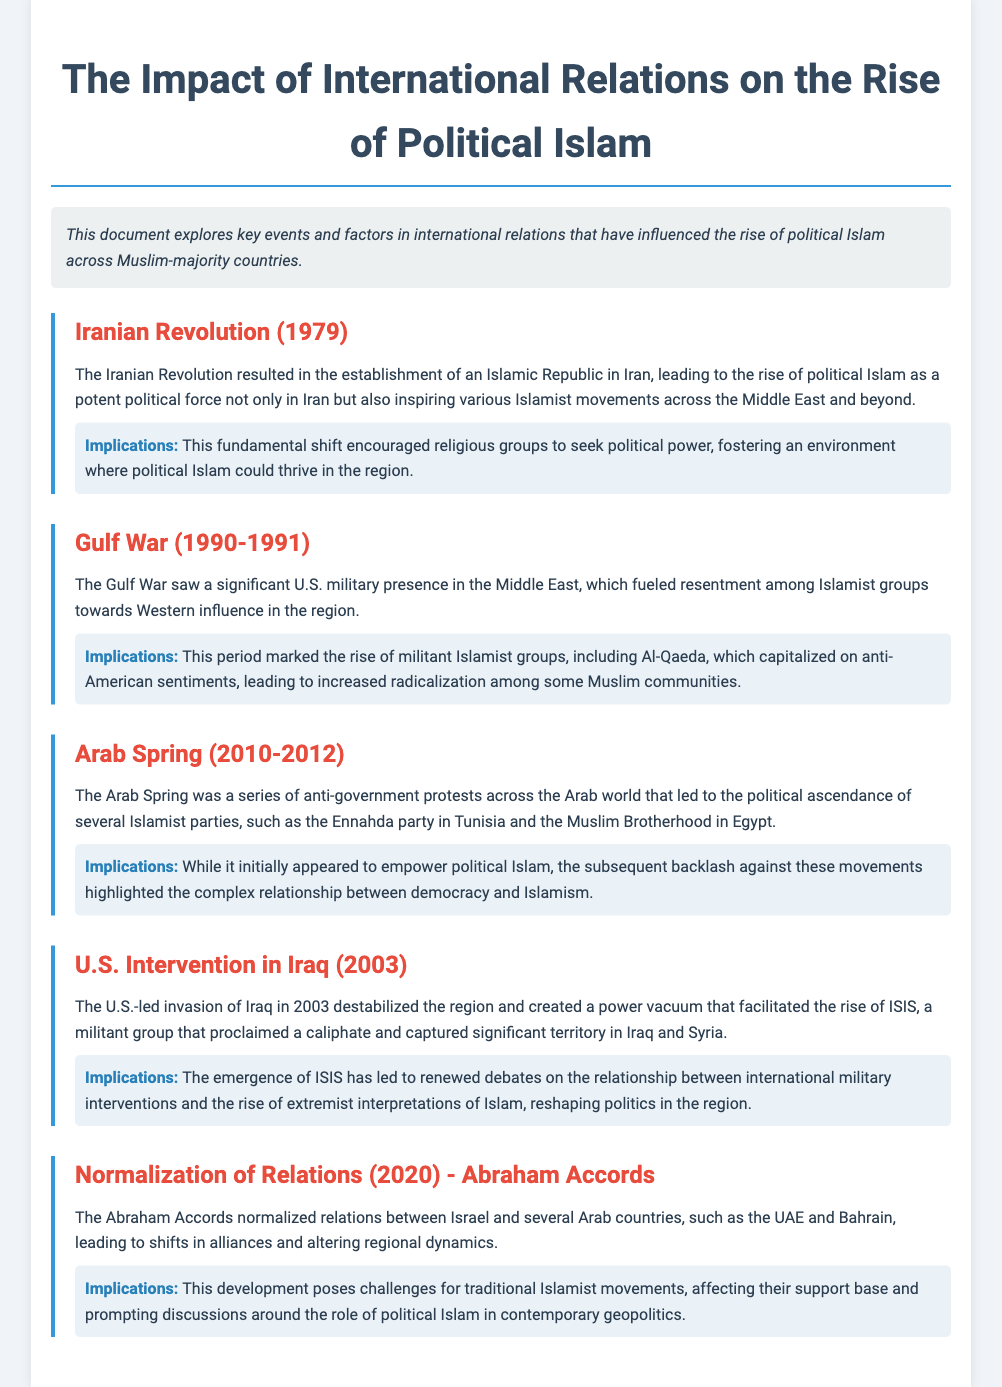What event established an Islamic Republic in Iran? The document states that the Iranian Revolution resulted in the establishment of an Islamic Republic in Iran.
Answer: Iranian Revolution What military action fueled resentment among Islamist groups in the Middle East? The Gulf War saw a significant U.S. military presence in the region, fuelling resentment.
Answer: Gulf War Which political movements gained prominence during the Arab Spring? The document mentions the Ennahda party in Tunisia and the Muslim Brotherhood in Egypt as key movements.
Answer: Ennahda party and the Muslim Brotherhood What year did the U.S. intervene in Iraq, creating instability in the region? According to the document, the U.S.-led invasion occurred in 2003.
Answer: 2003 What were the Abraham Accords aimed at? The document notes that the Abraham Accords normalized relations between Israel and several Arab countries.
Answer: Normalizing relations Which militant group emerged as a result of the power vacuum in Iraq? The document identifies ISIS as the militant group that rose in Iraq post-invasion.
Answer: ISIS How did the Gulf War contribute to the rise of radicalization? The document indicates that it marked the rise of militant Islamist groups, capitalizing on resentment.
Answer: Increased radicalization What aspect of political Islam did the backlash during the Arab Spring highlight? The backlash against Islamist movements underscored the complex relationship between democracy and Islamism.
Answer: Complex relationship What has the emergence of ISIS prompted discussions about? The document states it has led to debates on the relationship between international military interventions and extremist interpretations of Islam.
Answer: International military interventions and extremism 